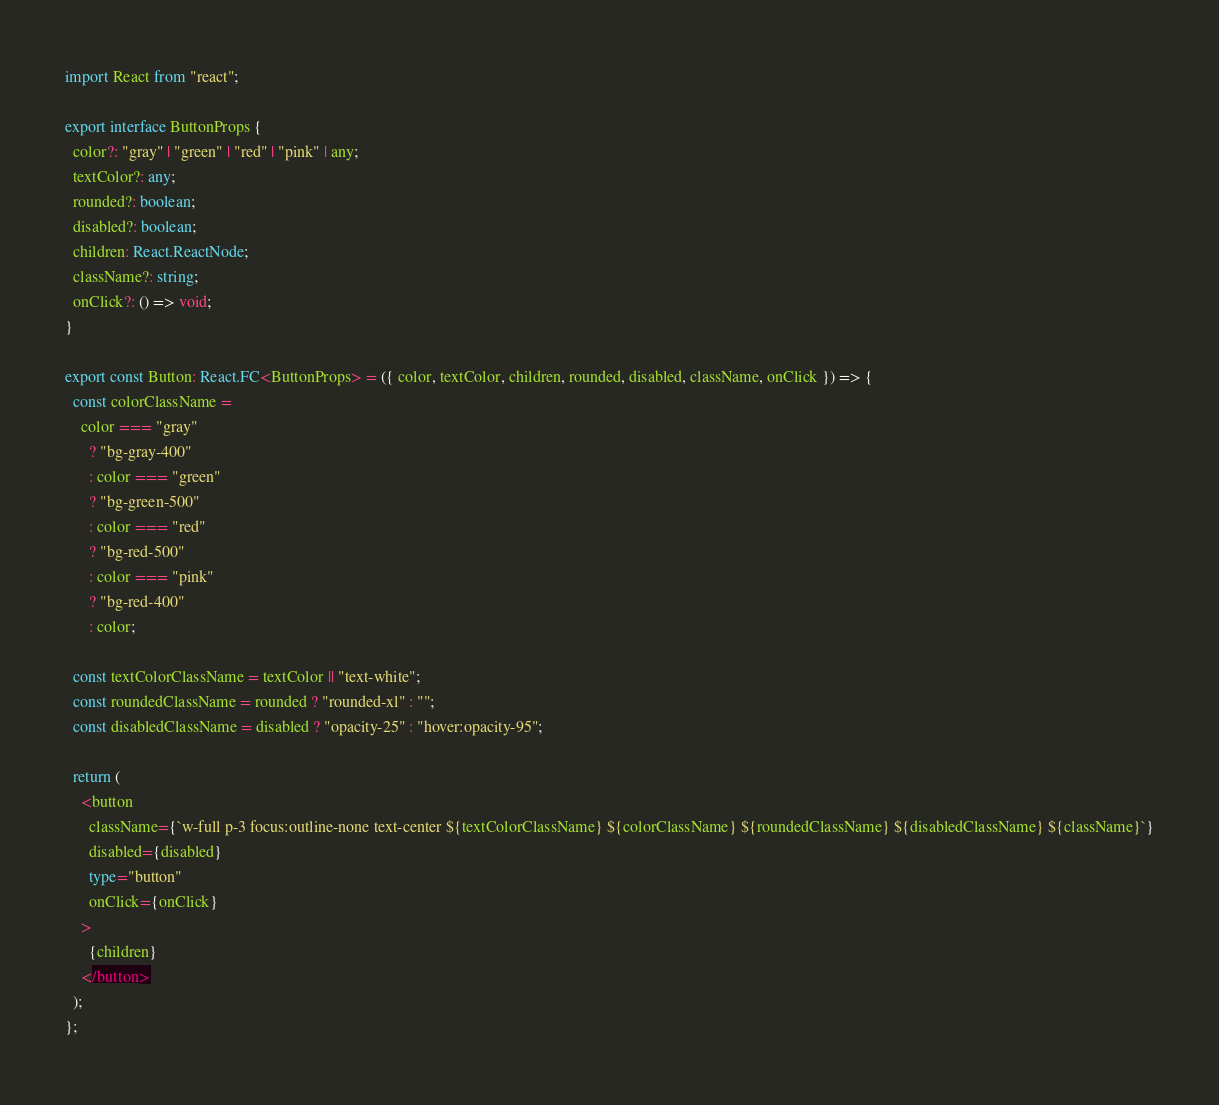<code> <loc_0><loc_0><loc_500><loc_500><_TypeScript_>import React from "react";

export interface ButtonProps {
  color?: "gray" | "green" | "red" | "pink" | any;
  textColor?: any;
  rounded?: boolean;
  disabled?: boolean;
  children: React.ReactNode;
  className?: string;
  onClick?: () => void;
}

export const Button: React.FC<ButtonProps> = ({ color, textColor, children, rounded, disabled, className, onClick }) => {
  const colorClassName =
    color === "gray"
      ? "bg-gray-400"
      : color === "green"
      ? "bg-green-500"
      : color === "red"
      ? "bg-red-500"
      : color === "pink"
      ? "bg-red-400"
      : color;

  const textColorClassName = textColor || "text-white";
  const roundedClassName = rounded ? "rounded-xl" : "";
  const disabledClassName = disabled ? "opacity-25" : "hover:opacity-95";

  return (
    <button
      className={`w-full p-3 focus:outline-none text-center ${textColorClassName} ${colorClassName} ${roundedClassName} ${disabledClassName} ${className}`}
      disabled={disabled}
      type="button"
      onClick={onClick}
    >
      {children}
    </button>
  );
};
</code> 